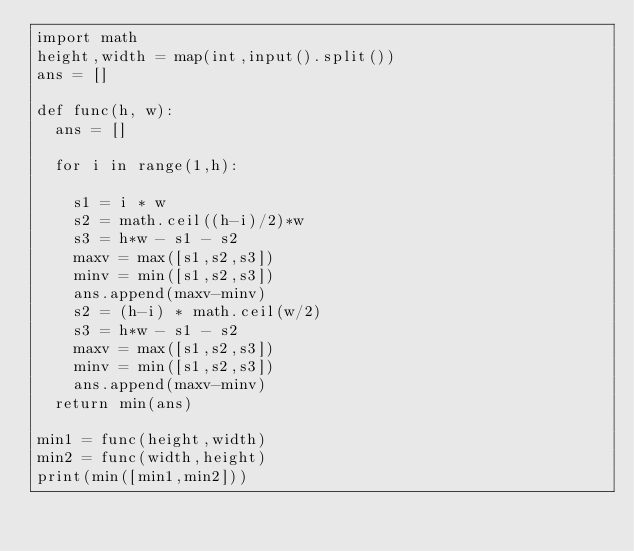Convert code to text. <code><loc_0><loc_0><loc_500><loc_500><_Python_>import math
height,width = map(int,input().split())
ans = []

def func(h, w):
  ans = []

  for i in range(1,h):

    s1 = i * w
    s2 = math.ceil((h-i)/2)*w
    s3 = h*w - s1 - s2
    maxv = max([s1,s2,s3])
    minv = min([s1,s2,s3])
    ans.append(maxv-minv)
    s2 = (h-i) * math.ceil(w/2)
    s3 = h*w - s1 - s2
    maxv = max([s1,s2,s3])
    minv = min([s1,s2,s3])
    ans.append(maxv-minv)
  return min(ans)
  
min1 = func(height,width)
min2 = func(width,height)
print(min([min1,min2]))</code> 